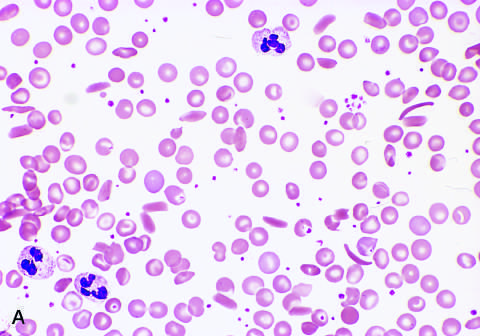does the cause of reversible injury show sickle cells, anisocytosis, poikilocytosis, and target cells?
Answer the question using a single word or phrase. No 